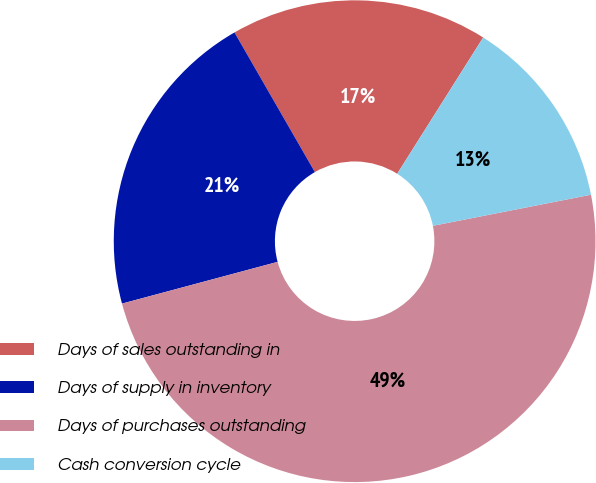<chart> <loc_0><loc_0><loc_500><loc_500><pie_chart><fcel>Days of sales outstanding in<fcel>Days of supply in inventory<fcel>Days of purchases outstanding<fcel>Cash conversion cycle<nl><fcel>17.27%<fcel>20.86%<fcel>48.92%<fcel>12.95%<nl></chart> 